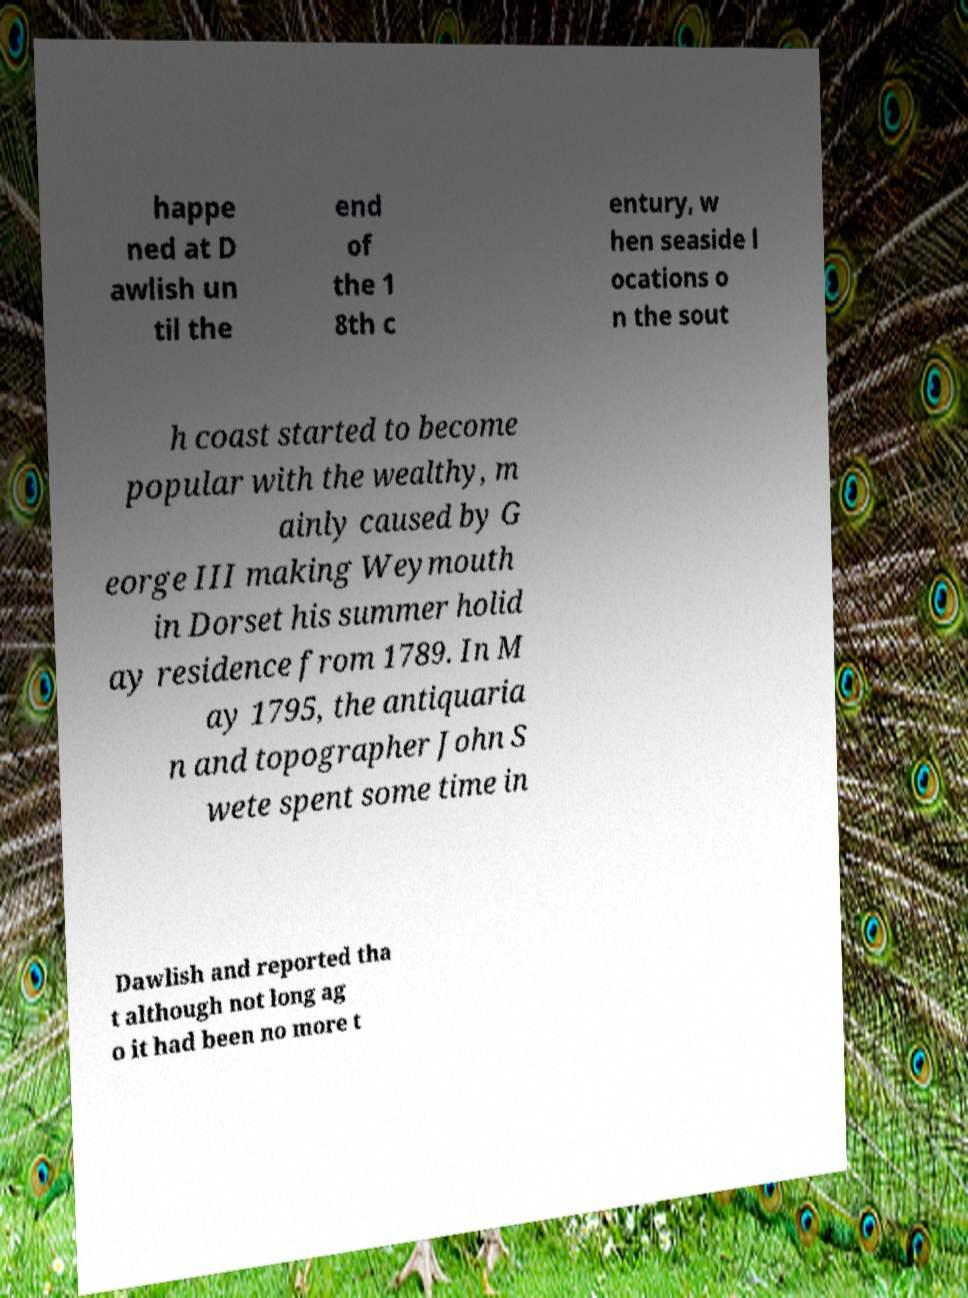I need the written content from this picture converted into text. Can you do that? happe ned at D awlish un til the end of the 1 8th c entury, w hen seaside l ocations o n the sout h coast started to become popular with the wealthy, m ainly caused by G eorge III making Weymouth in Dorset his summer holid ay residence from 1789. In M ay 1795, the antiquaria n and topographer John S wete spent some time in Dawlish and reported tha t although not long ag o it had been no more t 